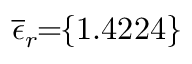<formula> <loc_0><loc_0><loc_500><loc_500>\, \overline { \epsilon } _ { r } \, = \, \{ 1 . 4 2 2 4 \} \,</formula> 